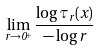<formula> <loc_0><loc_0><loc_500><loc_500>\lim _ { r \rightarrow 0 ^ { + } } \frac { \log \tau _ { r } ( x ) } { - \log r }</formula> 